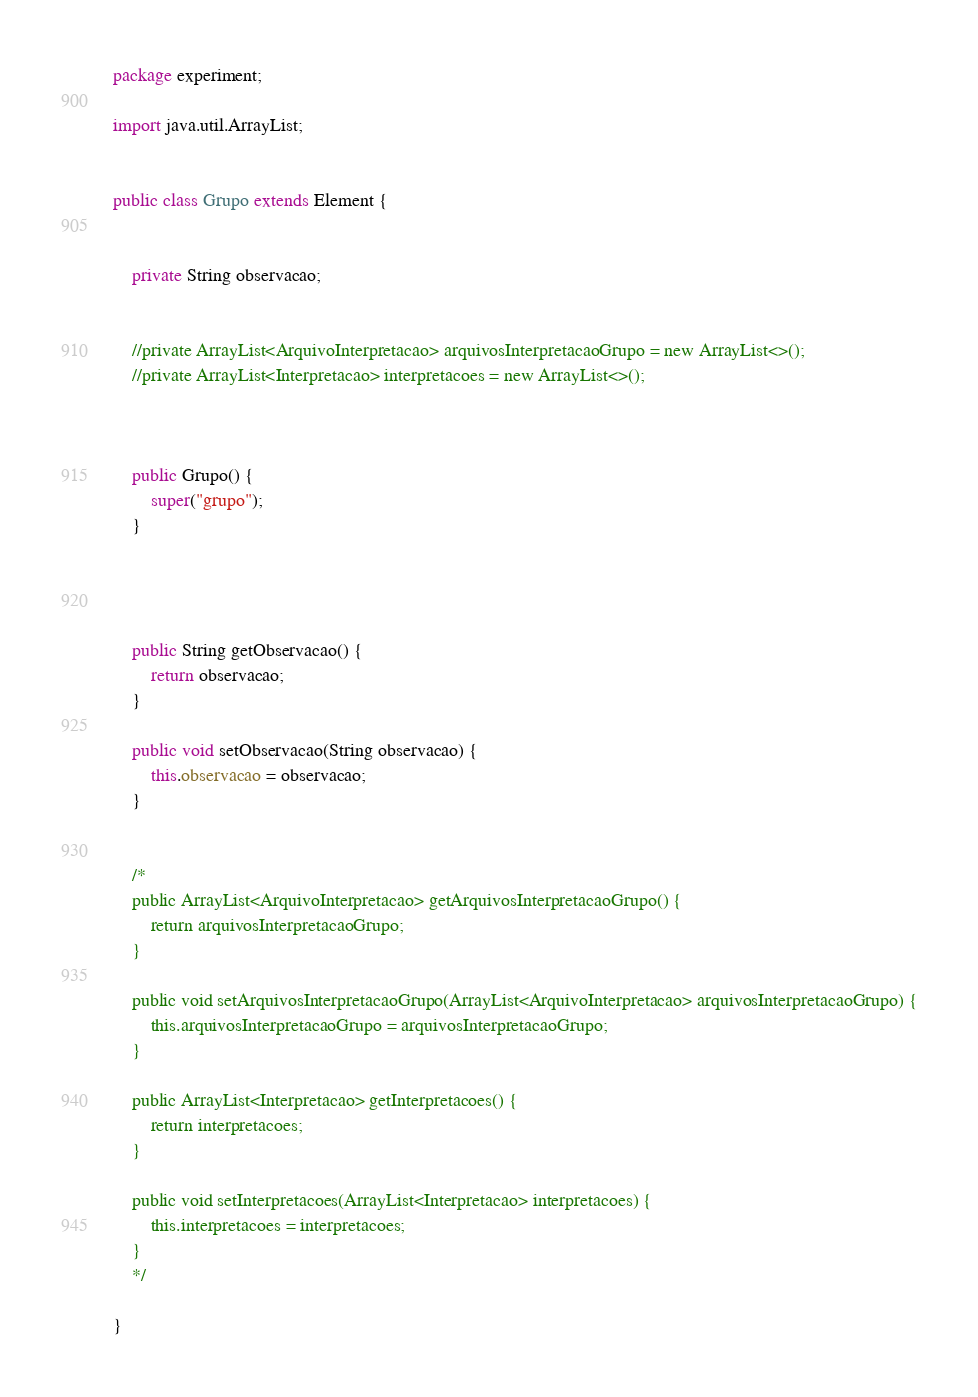<code> <loc_0><loc_0><loc_500><loc_500><_Java_>package experiment;

import java.util.ArrayList;


public class Grupo extends Element {

    
    private String observacao;
    
    
    //private ArrayList<ArquivoInterpretacao> arquivosInterpretacaoGrupo = new ArrayList<>();
    //private ArrayList<Interpretacao> interpretacoes = new ArrayList<>();
    
    
   
    public Grupo() {
        super("grupo");
    }


    

    public String getObservacao() {
        return observacao;
    }

    public void setObservacao(String observacao) {
        this.observacao = observacao;
    }

   
    /*
    public ArrayList<ArquivoInterpretacao> getArquivosInterpretacaoGrupo() {
        return arquivosInterpretacaoGrupo;
    }

    public void setArquivosInterpretacaoGrupo(ArrayList<ArquivoInterpretacao> arquivosInterpretacaoGrupo) {
        this.arquivosInterpretacaoGrupo = arquivosInterpretacaoGrupo;
    }

    public ArrayList<Interpretacao> getInterpretacoes() {
        return interpretacoes;
    }

    public void setInterpretacoes(ArrayList<Interpretacao> interpretacoes) {
        this.interpretacoes = interpretacoes;
    }
    */
    
}
</code> 